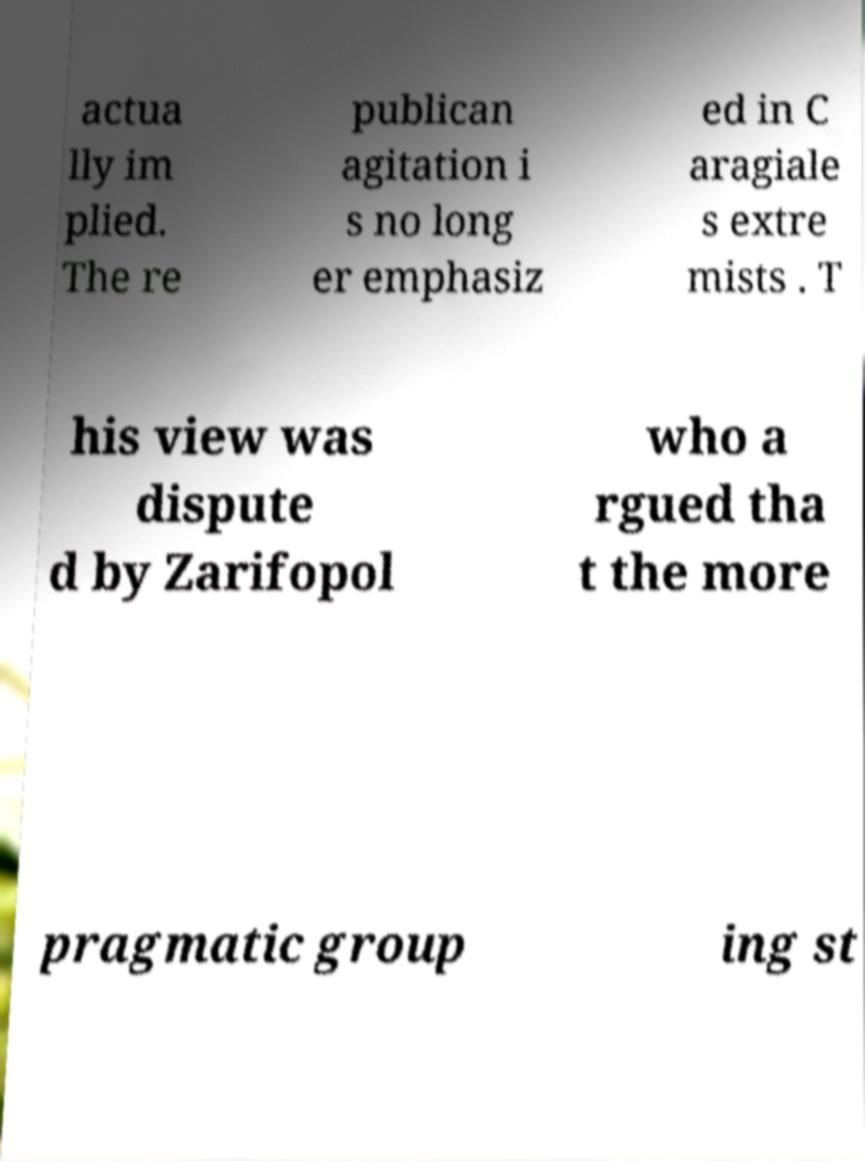Could you assist in decoding the text presented in this image and type it out clearly? actua lly im plied. The re publican agitation i s no long er emphasiz ed in C aragiale s extre mists . T his view was dispute d by Zarifopol who a rgued tha t the more pragmatic group ing st 